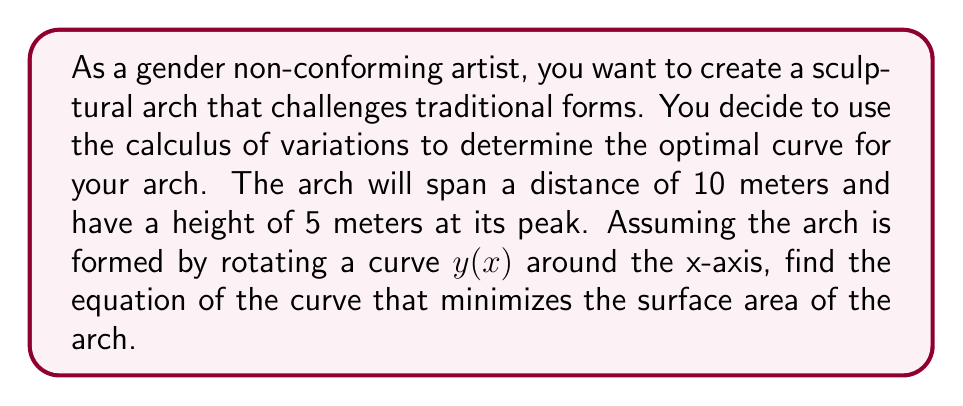Solve this math problem. To solve this problem, we'll use the calculus of variations and follow these steps:

1) The surface area of a surface of revolution is given by:
   $$A = 2\pi \int_0^{10} y \sqrt{1 + (y')^2} dx$$

2) We need to minimize this functional. The Euler-Lagrange equation for this problem is:
   $$\frac{\partial F}{\partial y} - \frac{d}{dx}\frac{\partial F}{\partial y'} = 0$$
   where $F = y \sqrt{1 + (y')^2}$

3) Calculating the partial derivatives:
   $$\frac{\partial F}{\partial y} = \sqrt{1 + (y')^2}$$
   $$\frac{\partial F}{\partial y'} = \frac{yy'}{\sqrt{1 + (y')^2}}$$

4) Substituting into the Euler-Lagrange equation:
   $$\sqrt{1 + (y')^2} - \frac{d}{dx}\left(\frac{yy'}{\sqrt{1 + (y')^2}}\right) = 0$$

5) This simplifies to:
   $$y'' = \frac{1 + (y')^2}{y}$$

6) This differential equation has the general solution:
   $$y = a \cosh(\frac{x-b}{a})$$
   where $a$ and $b$ are constants.

7) Using the boundary conditions:
   At $x=0$, $y=0$: $0 = a \cosh(-\frac{b}{a})$
   At $x=10$, $y=0$: $0 = a \cosh(\frac{10-b}{a})$
   At $x=5$, $y=5$: $5 = a \cosh(\frac{5-b}{a})$

8) From the first two conditions, we can deduce that $b=5$ (the midpoint).
   From the third condition: $a = 5 / \cosh(0) = 5$

Therefore, the equation of the curve is $y = 5 \cosh(\frac{x-5}{5})$.
Answer: The optimal curve for the sculptural arch is given by the equation:
$$y = 5 \cosh(\frac{x-5}{5})$$ 